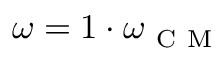Convert formula to latex. <formula><loc_0><loc_0><loc_500><loc_500>\omega = 1 \cdot \omega _ { C M }</formula> 